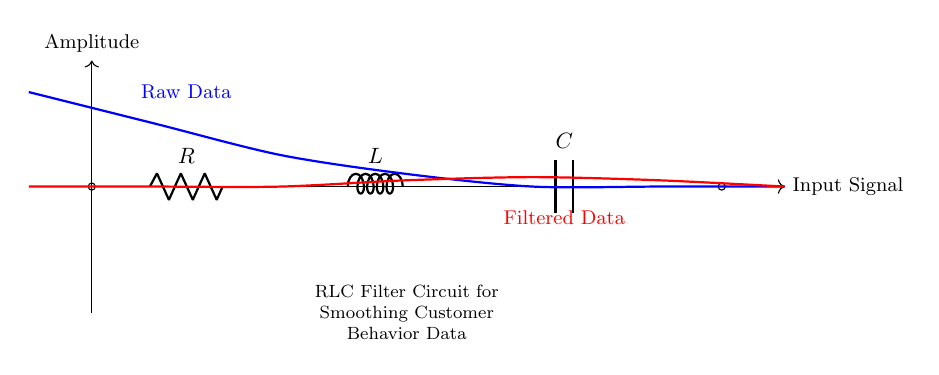What components are in this circuit? The circuit diagram contains a resistor, an inductor, and a capacitor, noted as R, L, and C respectively.
Answer: Resistor, Inductor, Capacitor What is the function of the RLC filter circuit? The RLC filter is designed to smooth customer behavior data by filtering high-frequency noise, allowing for a clearer signal output.
Answer: Smoothing data What does the blue line in the diagram represent? The blue line depicts the raw data signal, showing the amplitude of the data before filtering.
Answer: Raw Data What is the primary role of the resistor in the RLC filter? The resistor limits current flow and contributes to the damping of the circuit, reducing overshoot in the output signal.
Answer: Current limiting and damping How does the output data compare to the raw data? The filtered data, represented by the red line, shows a less variable signal compared to the raw data, indicating that noise has been reduced.
Answer: Less variable What happens to the amplitude of the filtered data by the end of the circuit? The amplitude of the filtered data approaches zero as it indicates that high-frequency components have been successfully eliminated from the signal.
Answer: Approaches zero 